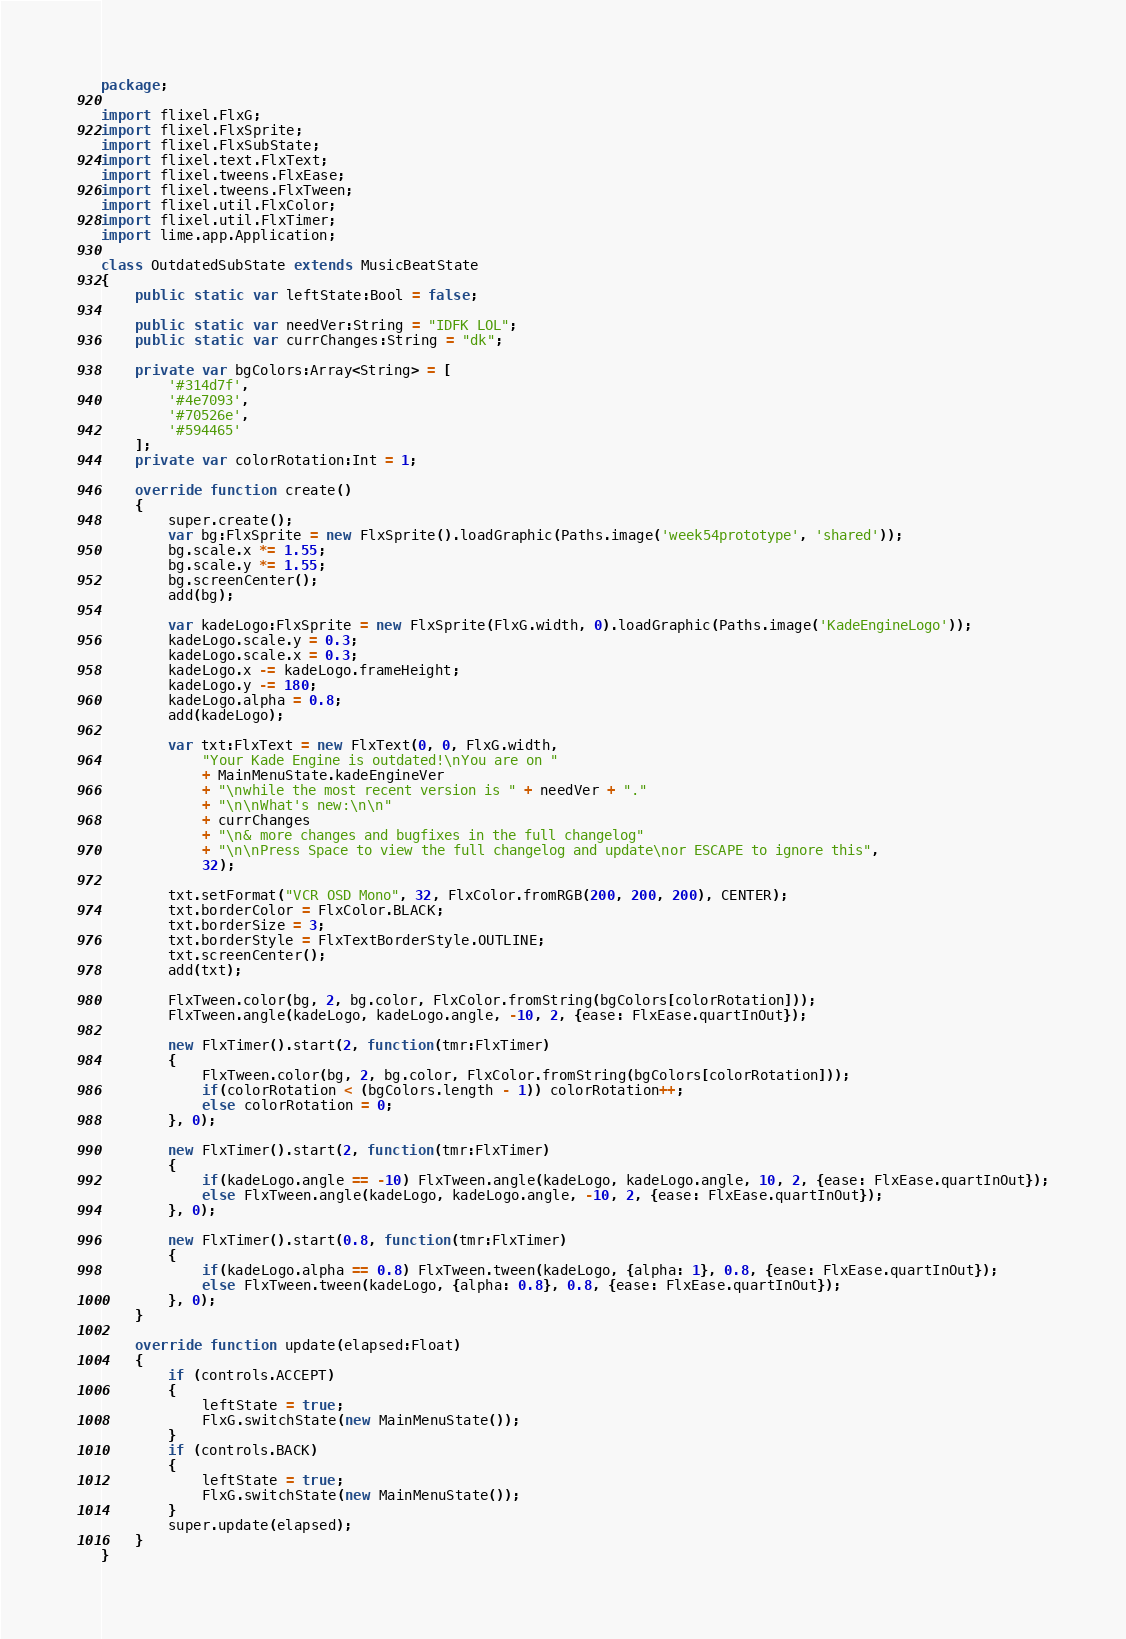Convert code to text. <code><loc_0><loc_0><loc_500><loc_500><_Haxe_>package;

import flixel.FlxG;
import flixel.FlxSprite;
import flixel.FlxSubState;
import flixel.text.FlxText;
import flixel.tweens.FlxEase;
import flixel.tweens.FlxTween;
import flixel.util.FlxColor;
import flixel.util.FlxTimer;
import lime.app.Application;

class OutdatedSubState extends MusicBeatState
{
	public static var leftState:Bool = false;

	public static var needVer:String = "IDFK LOL";
	public static var currChanges:String = "dk";
	
	private var bgColors:Array<String> = [
		'#314d7f',
		'#4e7093',
		'#70526e',
		'#594465'
	];
	private var colorRotation:Int = 1;

	override function create()
	{
		super.create();
		var bg:FlxSprite = new FlxSprite().loadGraphic(Paths.image('week54prototype', 'shared'));
		bg.scale.x *= 1.55;
		bg.scale.y *= 1.55;
		bg.screenCenter();
		add(bg);
		
		var kadeLogo:FlxSprite = new FlxSprite(FlxG.width, 0).loadGraphic(Paths.image('KadeEngineLogo'));
		kadeLogo.scale.y = 0.3;
		kadeLogo.scale.x = 0.3;
		kadeLogo.x -= kadeLogo.frameHeight;
		kadeLogo.y -= 180;
		kadeLogo.alpha = 0.8;
		add(kadeLogo);
		
		var txt:FlxText = new FlxText(0, 0, FlxG.width,
			"Your Kade Engine is outdated!\nYou are on "
			+ MainMenuState.kadeEngineVer
			+ "\nwhile the most recent version is " + needVer + "."
			+ "\n\nWhat's new:\n\n"
			+ currChanges
			+ "\n& more changes and bugfixes in the full changelog"
			+ "\n\nPress Space to view the full changelog and update\nor ESCAPE to ignore this",
			32);
		
		txt.setFormat("VCR OSD Mono", 32, FlxColor.fromRGB(200, 200, 200), CENTER);
		txt.borderColor = FlxColor.BLACK;
		txt.borderSize = 3;
		txt.borderStyle = FlxTextBorderStyle.OUTLINE;
		txt.screenCenter();
		add(txt);
		
		FlxTween.color(bg, 2, bg.color, FlxColor.fromString(bgColors[colorRotation]));
		FlxTween.angle(kadeLogo, kadeLogo.angle, -10, 2, {ease: FlxEase.quartInOut});
		
		new FlxTimer().start(2, function(tmr:FlxTimer)
		{
			FlxTween.color(bg, 2, bg.color, FlxColor.fromString(bgColors[colorRotation]));
			if(colorRotation < (bgColors.length - 1)) colorRotation++;
			else colorRotation = 0;
		}, 0);
		
		new FlxTimer().start(2, function(tmr:FlxTimer)
		{
			if(kadeLogo.angle == -10) FlxTween.angle(kadeLogo, kadeLogo.angle, 10, 2, {ease: FlxEase.quartInOut});
			else FlxTween.angle(kadeLogo, kadeLogo.angle, -10, 2, {ease: FlxEase.quartInOut});
		}, 0);
		
		new FlxTimer().start(0.8, function(tmr:FlxTimer)
		{
			if(kadeLogo.alpha == 0.8) FlxTween.tween(kadeLogo, {alpha: 1}, 0.8, {ease: FlxEase.quartInOut});
			else FlxTween.tween(kadeLogo, {alpha: 0.8}, 0.8, {ease: FlxEase.quartInOut});
		}, 0);
	}

	override function update(elapsed:Float)
	{
		if (controls.ACCEPT)
		{
			leftState = true;
			FlxG.switchState(new MainMenuState());
		}
		if (controls.BACK)
		{
			leftState = true;
			FlxG.switchState(new MainMenuState());
		}
		super.update(elapsed);
	}
}
</code> 